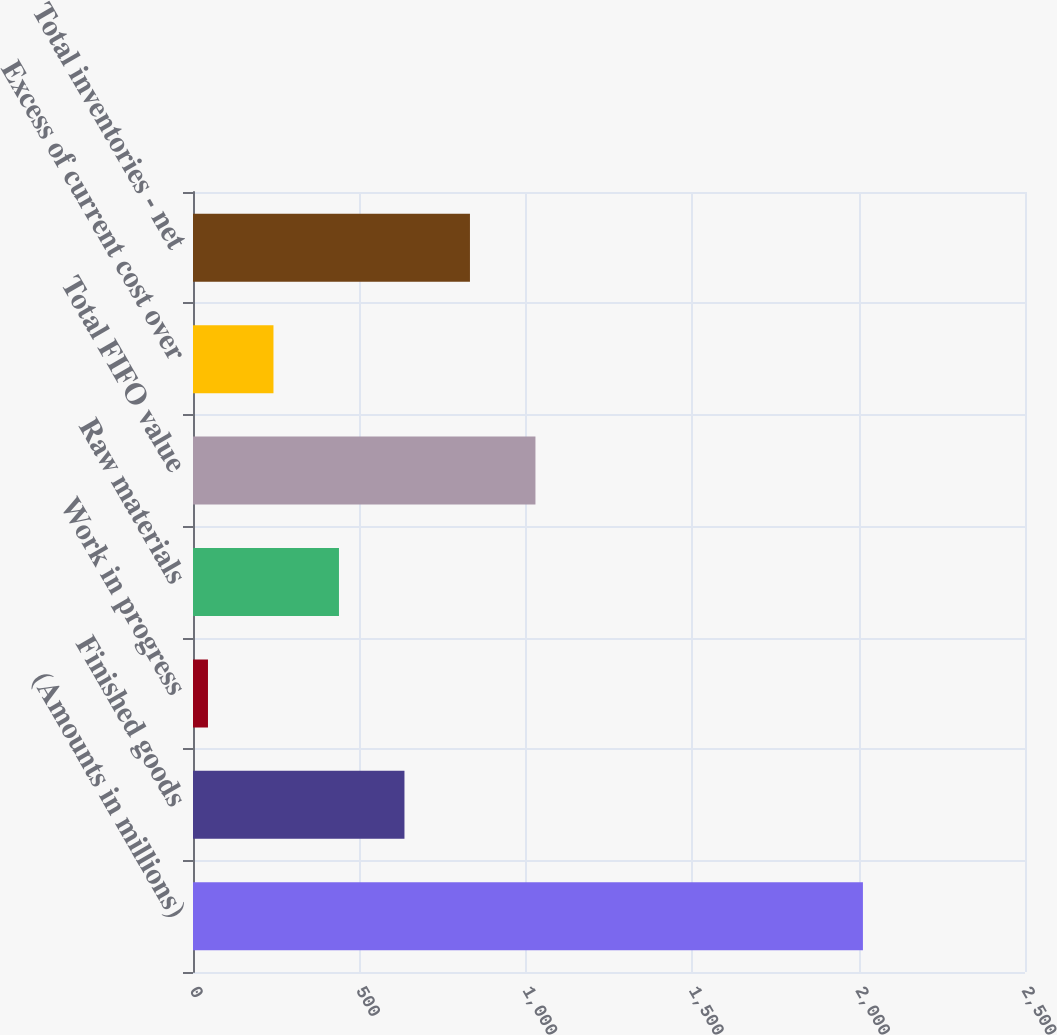Convert chart to OTSL. <chart><loc_0><loc_0><loc_500><loc_500><bar_chart><fcel>(Amounts in millions)<fcel>Finished goods<fcel>Work in progress<fcel>Raw materials<fcel>Total FIFO value<fcel>Excess of current cost over<fcel>Total inventories - net<nl><fcel>2013<fcel>635.4<fcel>45<fcel>438.6<fcel>1029<fcel>241.8<fcel>832.2<nl></chart> 